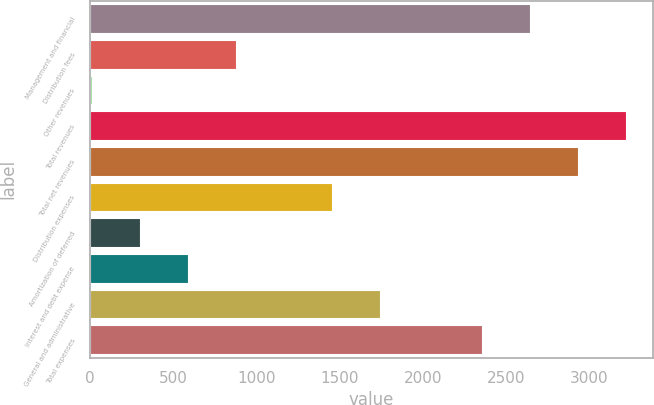Convert chart. <chart><loc_0><loc_0><loc_500><loc_500><bar_chart><fcel>Management and financial<fcel>Distribution fees<fcel>Other revenues<fcel>Total revenues<fcel>Total net revenues<fcel>Distribution expenses<fcel>Amortization of deferred<fcel>Interest and debt expense<fcel>General and administrative<fcel>Total expenses<nl><fcel>2644.1<fcel>876.3<fcel>12<fcel>3220.3<fcel>2932.2<fcel>1452.5<fcel>300.1<fcel>588.2<fcel>1740.6<fcel>2356<nl></chart> 